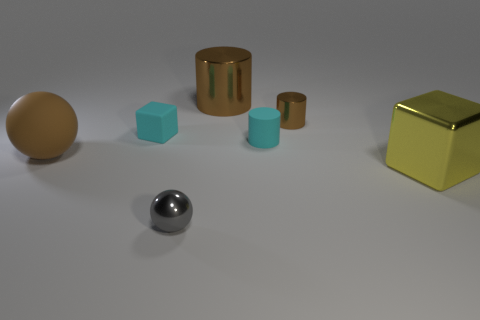What is the color of the shiny ball?
Provide a succinct answer. Gray. What number of big objects are purple blocks or brown balls?
Keep it short and to the point. 1. What material is the large sphere that is the same color as the large cylinder?
Provide a short and direct response. Rubber. Is the material of the object in front of the large yellow object the same as the block in front of the brown ball?
Your answer should be very brief. Yes. Are any tiny yellow shiny things visible?
Keep it short and to the point. No. Are there more small cyan matte things left of the tiny matte block than tiny rubber blocks that are in front of the small matte cylinder?
Ensure brevity in your answer.  No. What is the material of the other small thing that is the same shape as the small brown thing?
Your answer should be very brief. Rubber. Is there any other thing that is the same size as the gray ball?
Provide a short and direct response. Yes. Is the color of the cube to the left of the large cylinder the same as the sphere to the right of the matte ball?
Your answer should be very brief. No. The big yellow object has what shape?
Your answer should be compact. Cube. 